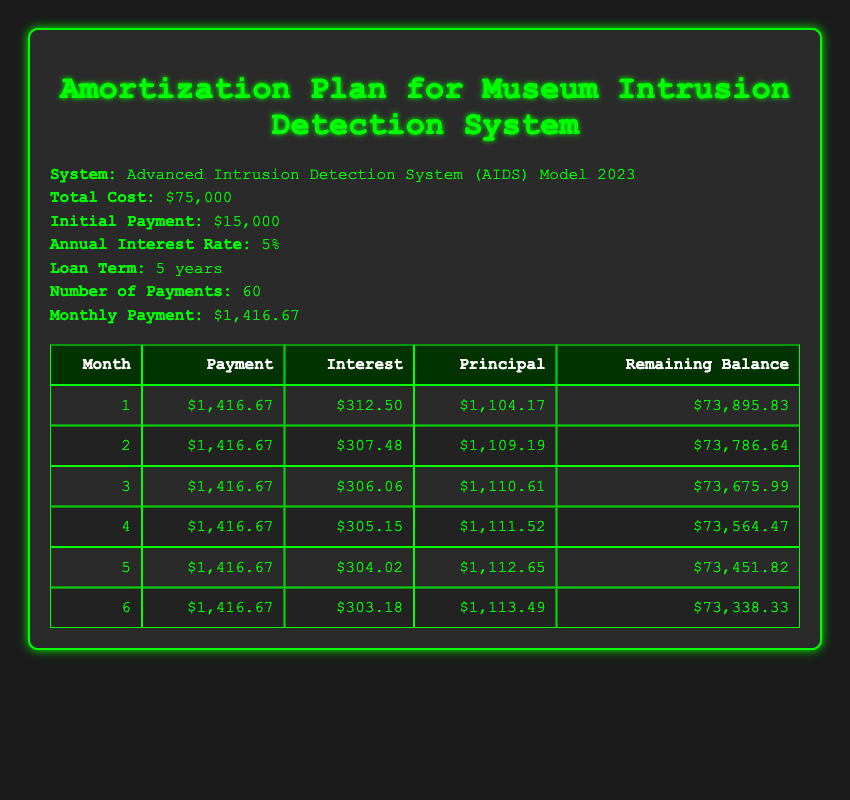What is the monthly payment for the Advanced Intrusion Detection System? The monthly payment is explicitly stated in the table under "Monthly Payment," which shows $1,416.67.
Answer: $1,416.67 How much interest is paid in the first month? The amount of interest paid in the first month is provided in the table under the first row for interest, which is $312.50.
Answer: $312.50 What is the total number of payments to be made for this system? The total number of payments is noted in the table, specifically under "Number of Payments," which indicates 60 payments total.
Answer: 60 What is the remaining balance after the second month? The remaining balance is listed for each month; for the second month, it is shown to be $73,786.64.
Answer: $73,786.64 How much principal is paid off in the fifth month? In the fifth month, the principal amount paid is directly found in the table under the principal column, which shows $1,112.65.
Answer: $1,112.65 Is the total interest paid in the first three months more than $900? Calculate the total interest for the first three months: $312.50 + $307.48 + $306.06 = $926.04, which is greater than $900.
Answer: Yes What is the average principal paid over the first six months? First, sum the principal amounts for the first six months: $1,104.17 + $1,109.19 + $1,110.61 + $1,111.52 + $1,112.65 + $1,113.49 = $6,126.63. Then, divide by 6 to get the average: $6,126.63 / 6 = $1,021.11.
Answer: $1,021.11 How much will the remaining balance decrease by after the first month? The starting balance is $75,000, and the remaining balance after the first month is $73,895.83. The decrease is calculated as: $75,000 - $73,895.83 = $1,104.17.
Answer: $1,104.17 What is the total amount of payments made after the first six months? Total payments made after six months can be calculated as 6 payments of $1,416.67 each: $1,416.67 * 6 = $8,500.02.
Answer: $8,500.02 